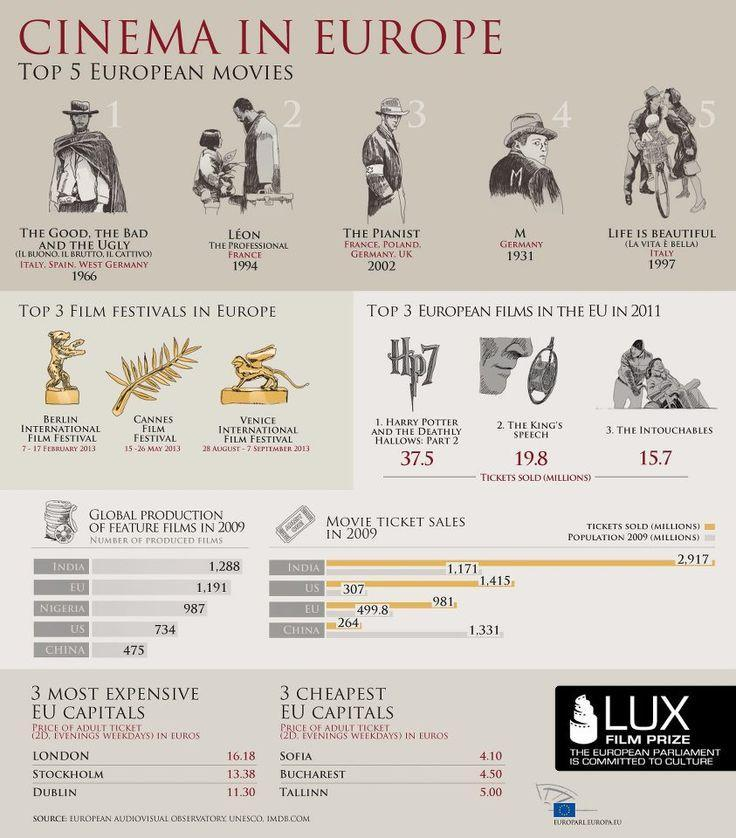How many films were produced in China in the year 2009?
Answer the question with a short phrase. 475 When was the Venice International Film Festival organized in Europe ? 28 AUGUST - 7 SEPTEMBER 2013 What is the number of movie tickets sold (in Millions) in U.S. in the year 2009? 1,415 How many films were produced in India in the year 2009? 1,288 Which was the top rated movie released in Germany in the year 1931? M Which was the top rated movie released in Italy in the year 1997? LIFE IS BEAUTIFUL When was the Cannes Film Festival organized in Europe? 15 - 26 MAY 2013 What is the number of  movie tickets sold (in Millions) in India in the year 2009? 2,917 What is the number of tickets sold (in Millions) for the movie 'The Intouchables' in the EU in 2011? 15.7 What is the number of tickets sold (in Millions) for the movie 'The King's Speech' in the EU in 2011? 19.8 